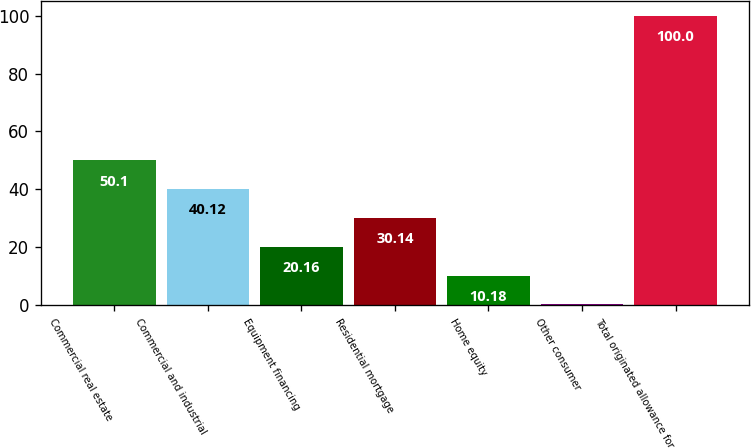Convert chart to OTSL. <chart><loc_0><loc_0><loc_500><loc_500><bar_chart><fcel>Commercial real estate<fcel>Commercial and industrial<fcel>Equipment financing<fcel>Residential mortgage<fcel>Home equity<fcel>Other consumer<fcel>Total originated allowance for<nl><fcel>50.1<fcel>40.12<fcel>20.16<fcel>30.14<fcel>10.18<fcel>0.2<fcel>100<nl></chart> 